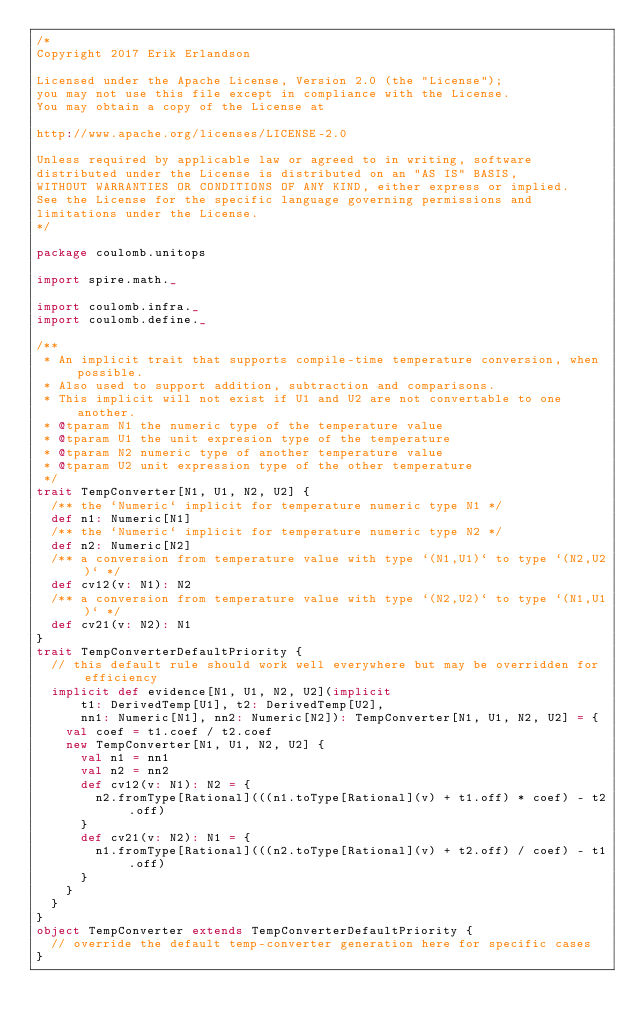<code> <loc_0><loc_0><loc_500><loc_500><_Scala_>/*
Copyright 2017 Erik Erlandson

Licensed under the Apache License, Version 2.0 (the "License");
you may not use this file except in compliance with the License.
You may obtain a copy of the License at

http://www.apache.org/licenses/LICENSE-2.0

Unless required by applicable law or agreed to in writing, software
distributed under the License is distributed on an "AS IS" BASIS,
WITHOUT WARRANTIES OR CONDITIONS OF ANY KIND, either express or implied.
See the License for the specific language governing permissions and
limitations under the License.
*/

package coulomb.unitops

import spire.math._

import coulomb.infra._
import coulomb.define._

/**
 * An implicit trait that supports compile-time temperature conversion, when possible.
 * Also used to support addition, subtraction and comparisons.
 * This implicit will not exist if U1 and U2 are not convertable to one another.
 * @tparam N1 the numeric type of the temperature value
 * @tparam U1 the unit expresion type of the temperature
 * @tparam N2 numeric type of another temperature value
 * @tparam U2 unit expression type of the other temperature
 */
trait TempConverter[N1, U1, N2, U2] {
  /** the `Numeric` implicit for temperature numeric type N1 */
  def n1: Numeric[N1]
  /** the `Numeric` implicit for temperature numeric type N2 */
  def n2: Numeric[N2]
  /** a conversion from temperature value with type `(N1,U1)` to type `(N2,U2)` */
  def cv12(v: N1): N2
  /** a conversion from temperature value with type `(N2,U2)` to type `(N1,U1)` */
  def cv21(v: N2): N1
}
trait TempConverterDefaultPriority {
  // this default rule should work well everywhere but may be overridden for efficiency
  implicit def evidence[N1, U1, N2, U2](implicit
      t1: DerivedTemp[U1], t2: DerivedTemp[U2],
      nn1: Numeric[N1], nn2: Numeric[N2]): TempConverter[N1, U1, N2, U2] = {
    val coef = t1.coef / t2.coef
    new TempConverter[N1, U1, N2, U2] {
      val n1 = nn1
      val n2 = nn2
      def cv12(v: N1): N2 = {
        n2.fromType[Rational](((n1.toType[Rational](v) + t1.off) * coef) - t2.off)
      }
      def cv21(v: N2): N1 = {
        n1.fromType[Rational](((n2.toType[Rational](v) + t2.off) / coef) - t1.off)
      }
    }
  }
}
object TempConverter extends TempConverterDefaultPriority {
  // override the default temp-converter generation here for specific cases
}
</code> 